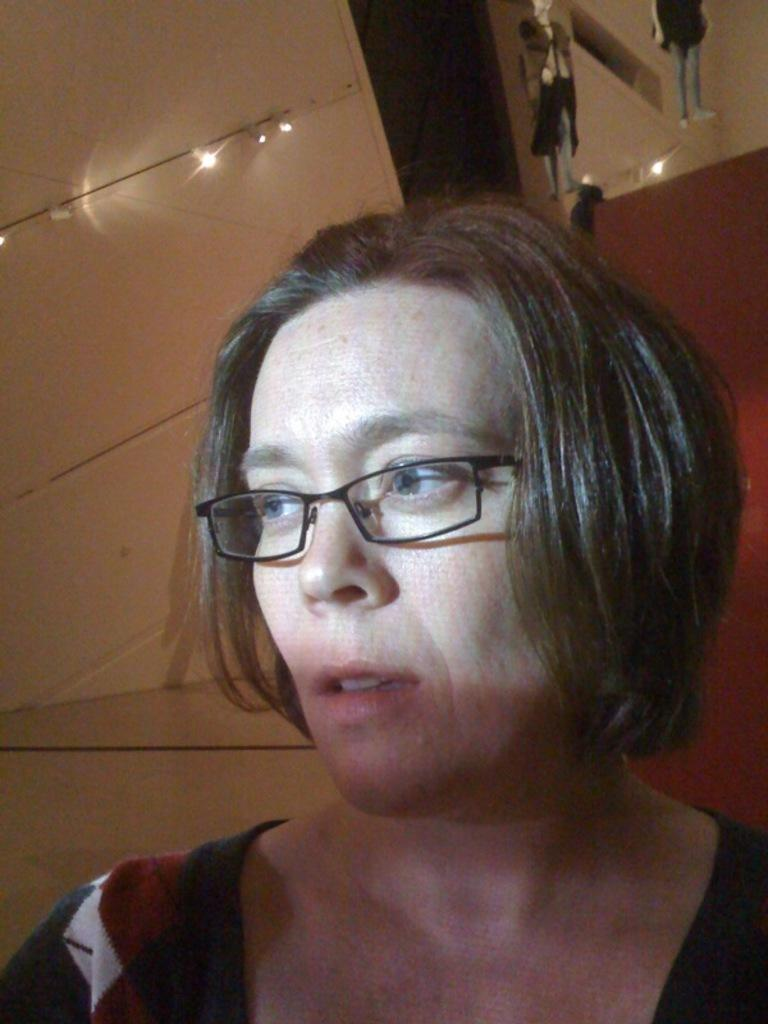Who is present in the image? There is a woman in the image. What accessory is the woman wearing? The woman is wearing spectacles. What can be seen in the background of the image? There are lights and other objects in the background of the image. What type of field can be seen in the image? There is no field present in the image; it features a woman wearing spectacles with lights and other objects in the background. 